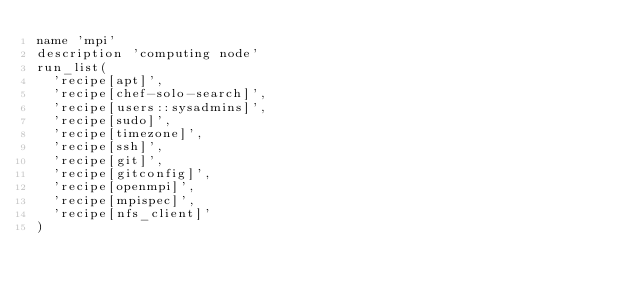Convert code to text. <code><loc_0><loc_0><loc_500><loc_500><_Ruby_>name 'mpi'
description 'computing node'
run_list(
  'recipe[apt]',
  'recipe[chef-solo-search]',
  'recipe[users::sysadmins]',
  'recipe[sudo]',
  'recipe[timezone]',
  'recipe[ssh]',
  'recipe[git]',
  'recipe[gitconfig]',
  'recipe[openmpi]',
  'recipe[mpispec]',
  'recipe[nfs_client]'
)
</code> 